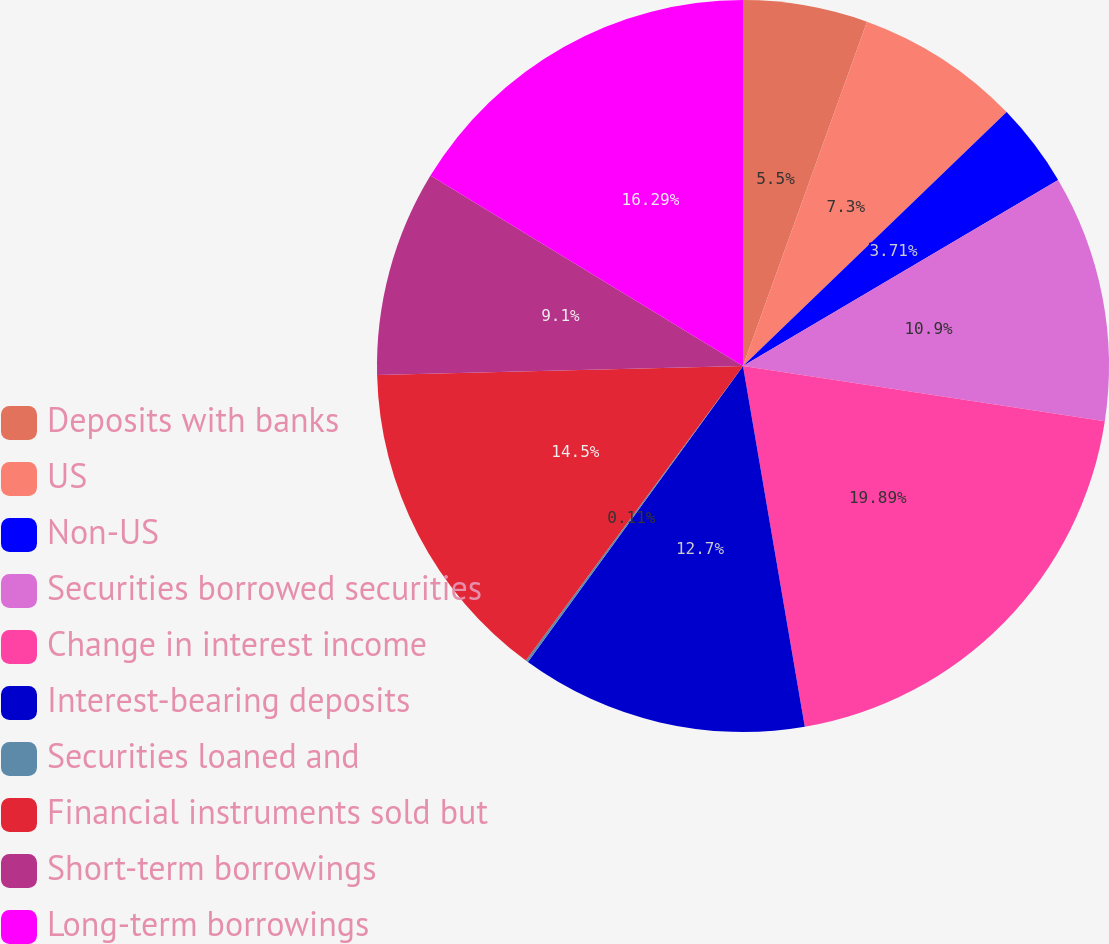<chart> <loc_0><loc_0><loc_500><loc_500><pie_chart><fcel>Deposits with banks<fcel>US<fcel>Non-US<fcel>Securities borrowed securities<fcel>Change in interest income<fcel>Interest-bearing deposits<fcel>Securities loaned and<fcel>Financial instruments sold but<fcel>Short-term borrowings<fcel>Long-term borrowings<nl><fcel>5.5%<fcel>7.3%<fcel>3.71%<fcel>10.9%<fcel>19.89%<fcel>12.7%<fcel>0.11%<fcel>14.5%<fcel>9.1%<fcel>16.29%<nl></chart> 